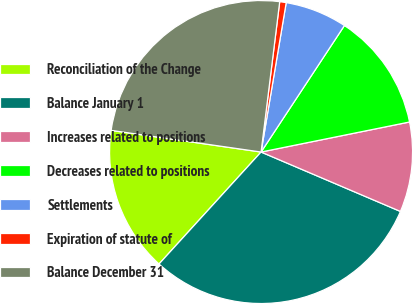Convert chart. <chart><loc_0><loc_0><loc_500><loc_500><pie_chart><fcel>Reconciliation of the Change<fcel>Balance January 1<fcel>Increases related to positions<fcel>Decreases related to positions<fcel>Settlements<fcel>Expiration of statute of<fcel>Balance December 31<nl><fcel>15.52%<fcel>30.35%<fcel>9.59%<fcel>12.55%<fcel>6.62%<fcel>0.69%<fcel>24.68%<nl></chart> 